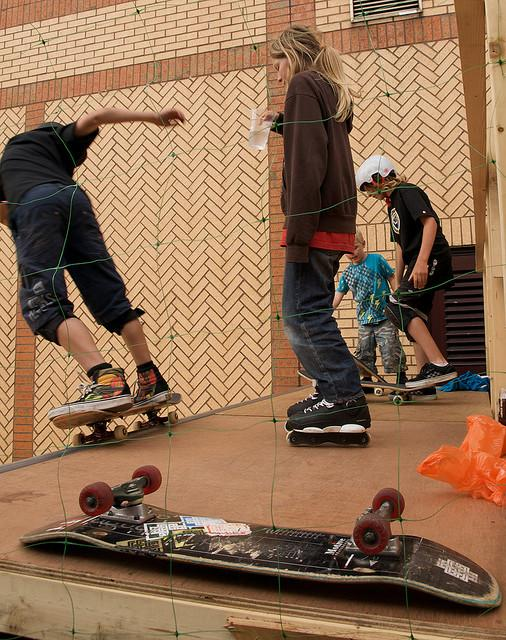This girl has similar hair color to what actress?

Choices:
A) isabelle adjani
B) brooke shields
C) jessica chastain
D) michelle pfeiffer michelle pfeiffer 